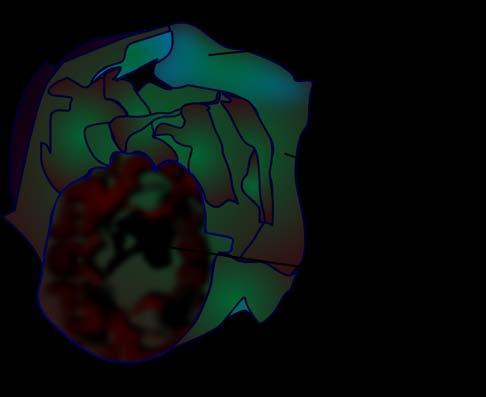what does cut surface show without papillae?
Answer the question using a single word or phrase. A very large multilocular cyst 